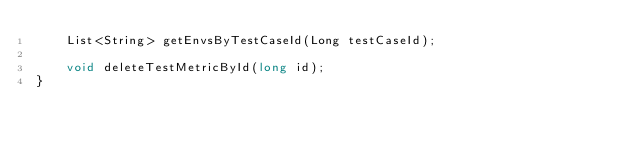Convert code to text. <code><loc_0><loc_0><loc_500><loc_500><_Java_>    List<String> getEnvsByTestCaseId(Long testCaseId);

    void deleteTestMetricById(long id);
}
</code> 